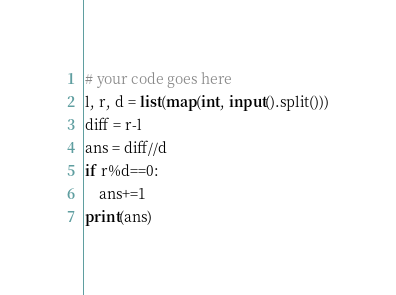<code> <loc_0><loc_0><loc_500><loc_500><_Python_># your code goes here
l, r, d = list(map(int, input().split()))
diff = r-l
ans = diff//d
if r%d==0:
	ans+=1
print(ans)</code> 